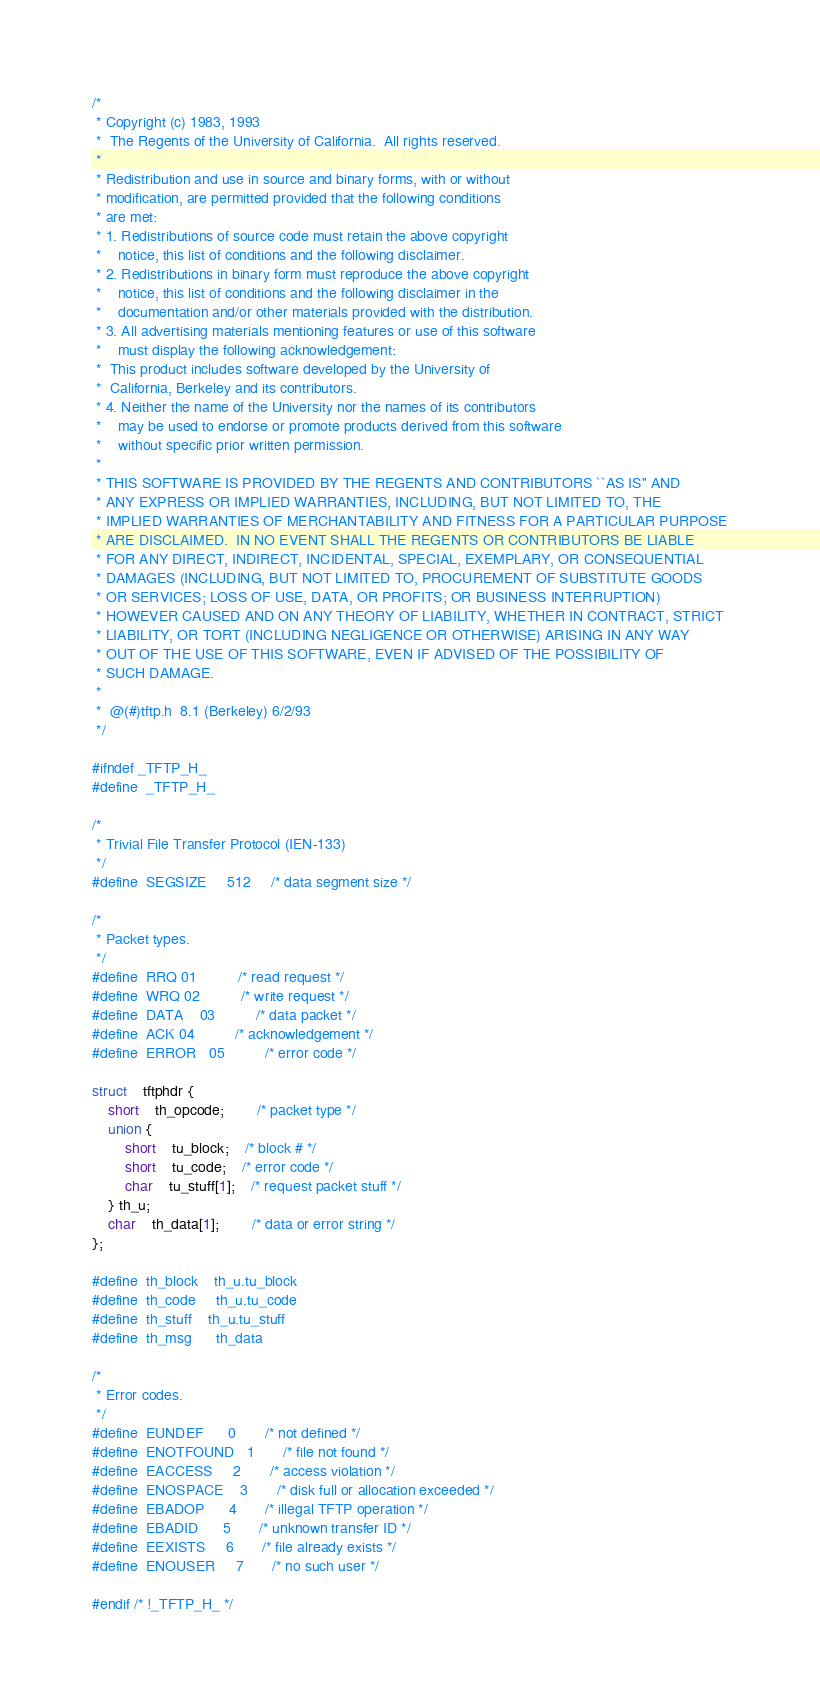<code> <loc_0><loc_0><loc_500><loc_500><_C_>/*
 * Copyright (c) 1983, 1993
 *	The Regents of the University of California.  All rights reserved.
 *
 * Redistribution and use in source and binary forms, with or without
 * modification, are permitted provided that the following conditions
 * are met:
 * 1. Redistributions of source code must retain the above copyright
 *    notice, this list of conditions and the following disclaimer.
 * 2. Redistributions in binary form must reproduce the above copyright
 *    notice, this list of conditions and the following disclaimer in the
 *    documentation and/or other materials provided with the distribution.
 * 3. All advertising materials mentioning features or use of this software
 *    must display the following acknowledgement:
 *	This product includes software developed by the University of
 *	California, Berkeley and its contributors.
 * 4. Neither the name of the University nor the names of its contributors
 *    may be used to endorse or promote products derived from this software
 *    without specific prior written permission.
 *
 * THIS SOFTWARE IS PROVIDED BY THE REGENTS AND CONTRIBUTORS ``AS IS'' AND
 * ANY EXPRESS OR IMPLIED WARRANTIES, INCLUDING, BUT NOT LIMITED TO, THE
 * IMPLIED WARRANTIES OF MERCHANTABILITY AND FITNESS FOR A PARTICULAR PURPOSE
 * ARE DISCLAIMED.  IN NO EVENT SHALL THE REGENTS OR CONTRIBUTORS BE LIABLE
 * FOR ANY DIRECT, INDIRECT, INCIDENTAL, SPECIAL, EXEMPLARY, OR CONSEQUENTIAL
 * DAMAGES (INCLUDING, BUT NOT LIMITED TO, PROCUREMENT OF SUBSTITUTE GOODS
 * OR SERVICES; LOSS OF USE, DATA, OR PROFITS; OR BUSINESS INTERRUPTION)
 * HOWEVER CAUSED AND ON ANY THEORY OF LIABILITY, WHETHER IN CONTRACT, STRICT
 * LIABILITY, OR TORT (INCLUDING NEGLIGENCE OR OTHERWISE) ARISING IN ANY WAY
 * OUT OF THE USE OF THIS SOFTWARE, EVEN IF ADVISED OF THE POSSIBILITY OF
 * SUCH DAMAGE.
 *
 *	@(#)tftp.h	8.1 (Berkeley) 6/2/93
 */

#ifndef _TFTP_H_
#define	_TFTP_H_

/*
 * Trivial File Transfer Protocol (IEN-133)
 */
#define	SEGSIZE		512		/* data segment size */

/*
 * Packet types.
 */
#define	RRQ	01			/* read request */
#define	WRQ	02			/* write request */
#define	DATA	03			/* data packet */
#define	ACK	04			/* acknowledgement */
#define	ERROR	05			/* error code */

struct	tftphdr {
	short	th_opcode;		/* packet type */
	union {
		short	tu_block;	/* block # */
		short	tu_code;	/* error code */
		char	tu_stuff[1];	/* request packet stuff */
	} th_u;
	char	th_data[1];		/* data or error string */
};

#define	th_block	th_u.tu_block
#define	th_code		th_u.tu_code
#define	th_stuff	th_u.tu_stuff
#define	th_msg		th_data

/*
 * Error codes.
 */
#define	EUNDEF		0		/* not defined */
#define	ENOTFOUND	1		/* file not found */
#define	EACCESS		2		/* access violation */
#define	ENOSPACE	3		/* disk full or allocation exceeded */
#define	EBADOP		4		/* illegal TFTP operation */
#define	EBADID		5		/* unknown transfer ID */
#define	EEXISTS		6		/* file already exists */
#define	ENOUSER		7		/* no such user */

#endif /* !_TFTP_H_ */
</code> 